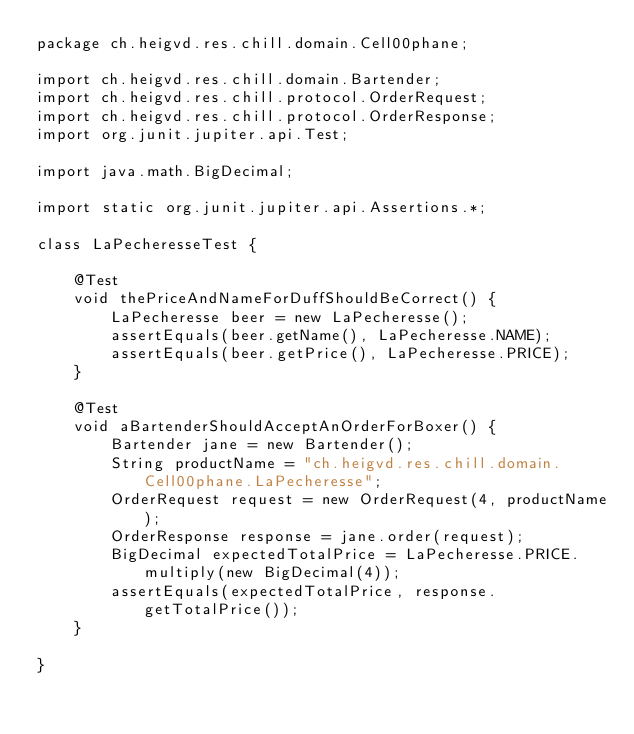<code> <loc_0><loc_0><loc_500><loc_500><_Java_>package ch.heigvd.res.chill.domain.Cell00phane;

import ch.heigvd.res.chill.domain.Bartender;
import ch.heigvd.res.chill.protocol.OrderRequest;
import ch.heigvd.res.chill.protocol.OrderResponse;
import org.junit.jupiter.api.Test;

import java.math.BigDecimal;

import static org.junit.jupiter.api.Assertions.*;

class LaPecheresseTest {

    @Test
    void thePriceAndNameForDuffShouldBeCorrect() {
        LaPecheresse beer = new LaPecheresse();
        assertEquals(beer.getName(), LaPecheresse.NAME);
        assertEquals(beer.getPrice(), LaPecheresse.PRICE);
    }

    @Test
    void aBartenderShouldAcceptAnOrderForBoxer() {
        Bartender jane = new Bartender();
        String productName = "ch.heigvd.res.chill.domain.Cell00phane.LaPecheresse";
        OrderRequest request = new OrderRequest(4, productName);
        OrderResponse response = jane.order(request);
        BigDecimal expectedTotalPrice = LaPecheresse.PRICE.multiply(new BigDecimal(4));
        assertEquals(expectedTotalPrice, response.getTotalPrice());
    }

}</code> 